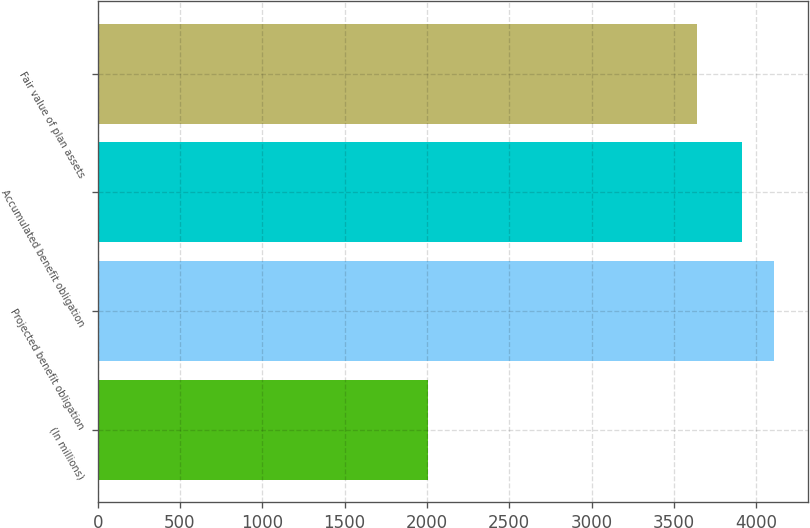Convert chart. <chart><loc_0><loc_0><loc_500><loc_500><bar_chart><fcel>(In millions)<fcel>Projected benefit obligation<fcel>Accumulated benefit obligation<fcel>Fair value of plan assets<nl><fcel>2006<fcel>4109.7<fcel>3912<fcel>3639<nl></chart> 